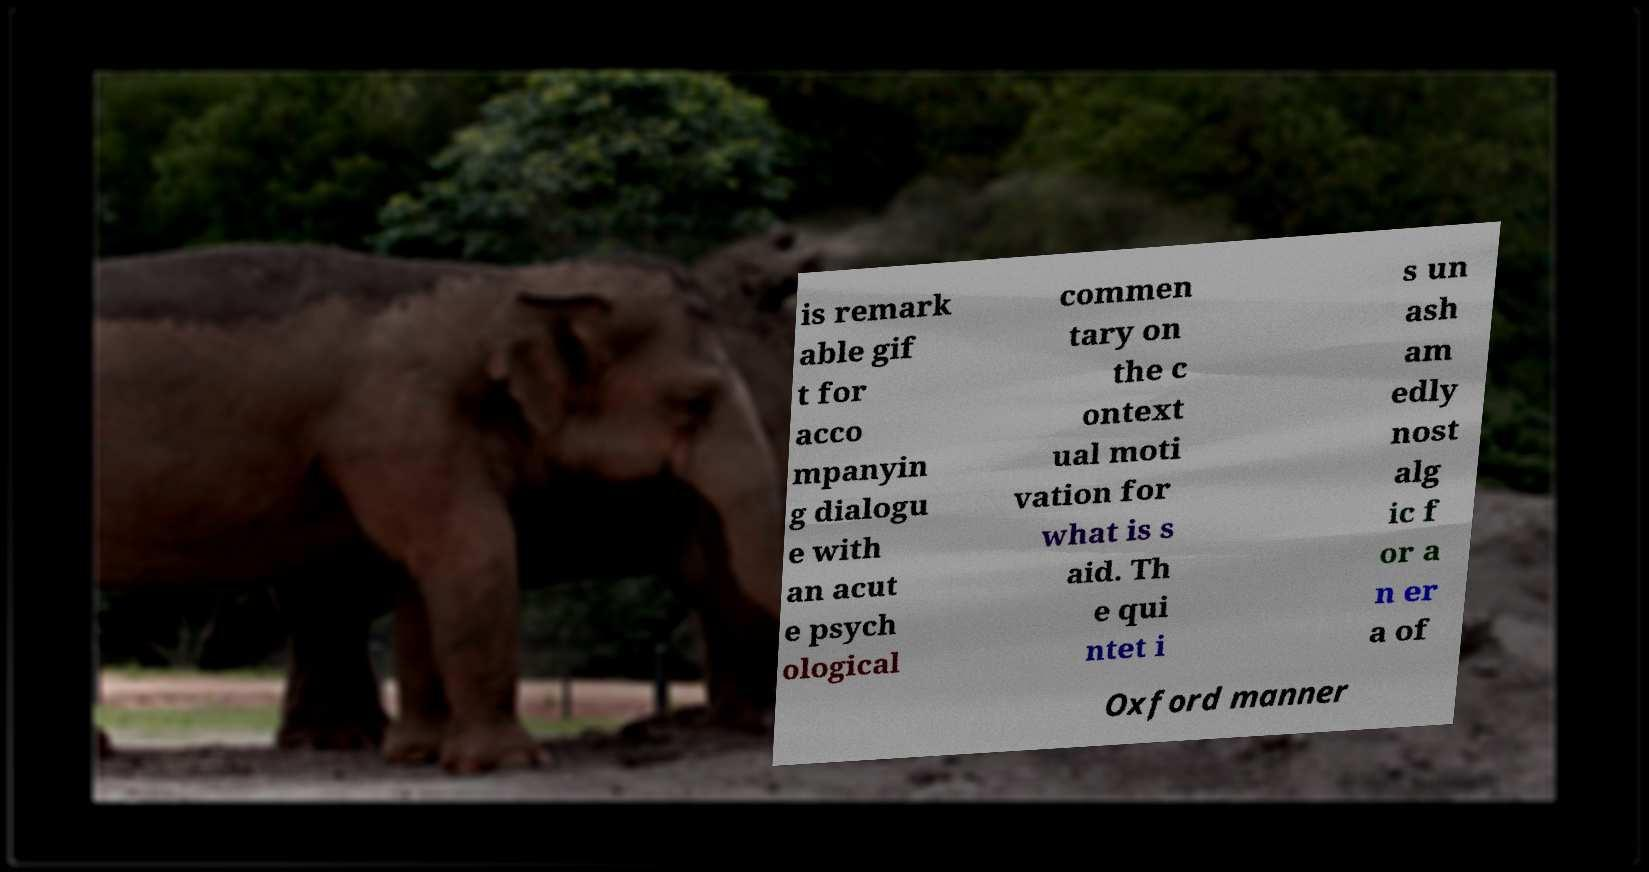Please read and relay the text visible in this image. What does it say? is remark able gif t for acco mpanyin g dialogu e with an acut e psych ological commen tary on the c ontext ual moti vation for what is s aid. Th e qui ntet i s un ash am edly nost alg ic f or a n er a of Oxford manner 